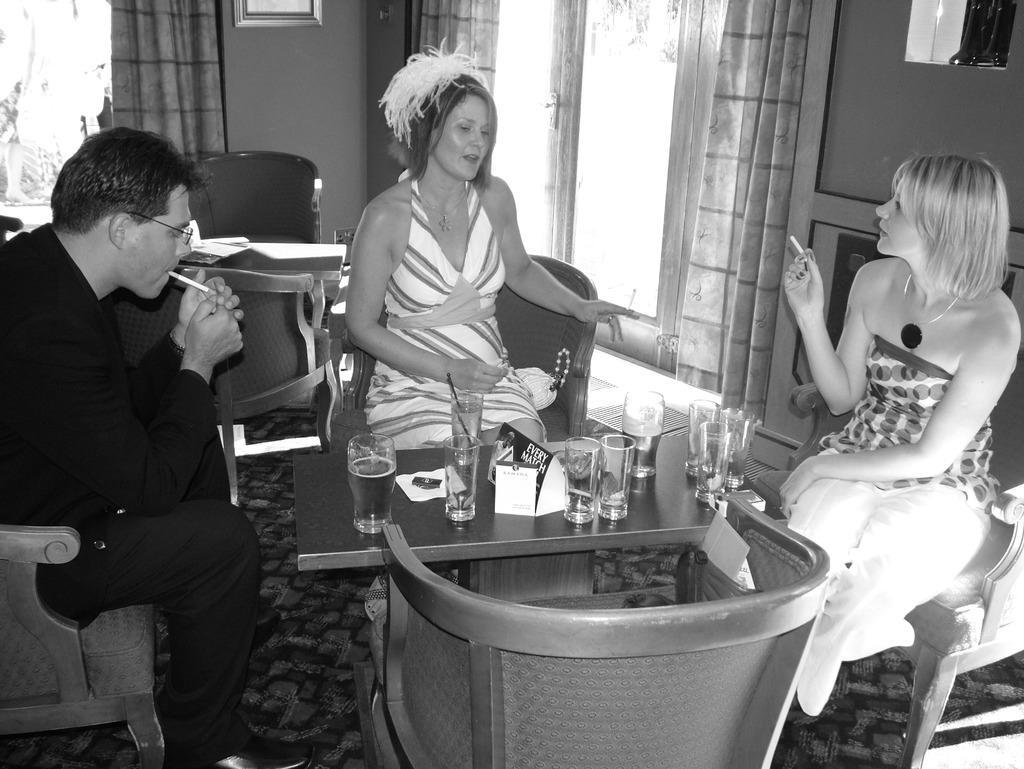How would you summarize this image in a sentence or two? This is a black and white picture, in this image we can see three persons sitting on the chairs, among them, two persons are smoking, also we can see the tables, on the tables, we can see the glasses and some other objects on it, there are curtains, doors, chairs and photo frames on the wall 